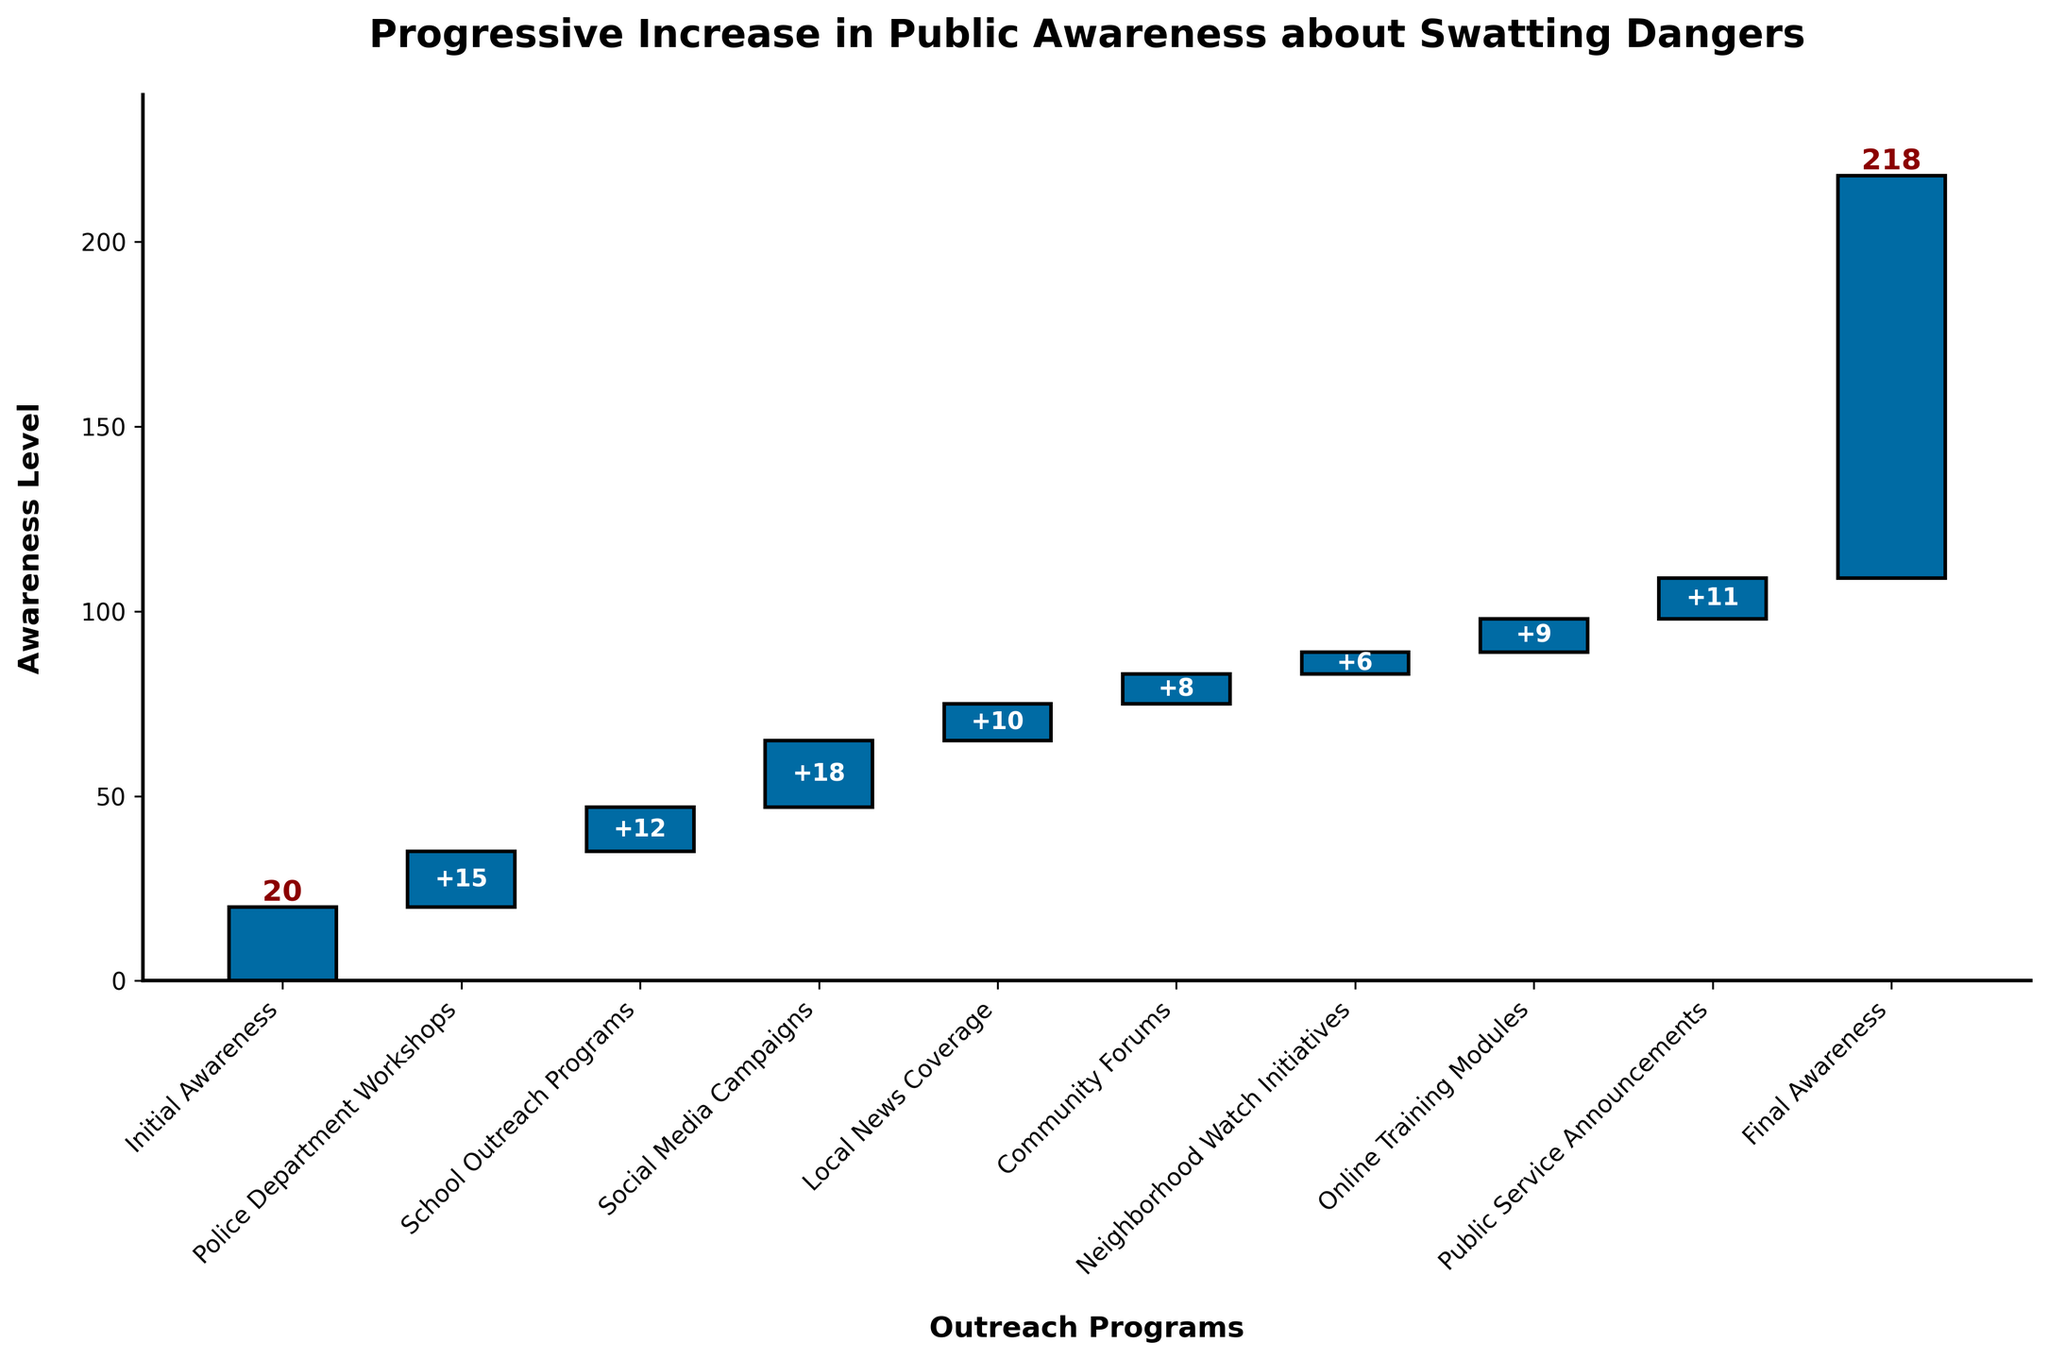What is the title of the figure? The title of the figure is found at the top of the chart. It reads "Progressive Increase in Public Awareness about Swatting Dangers".
Answer: Progressive Increase in Public Awareness about Swatting Dangers How many outreach programs are listed in the figure? Counting each unique category from the bar chart except for "Initial Awareness" and "Final Awareness" gives the total number of outreach programs. The programs are "Police Department Workshops", "School Outreach Programs", "Social Media Campaigns", "Local News Coverage", "Community Forums", "Neighborhood Watch Initiatives", "Online Training Modules", "Public Service Announcements". There are 8 programs in total.
Answer: 8 Which outreach program contributed the most to public awareness? By examining the bars, the height of each bar represents the contribution to public awareness. "Social Media Campaigns" has the tallest bar, indicating it contributed the most.
Answer: Social Media Campaigns What is the total increase in awareness from the initial to the final awareness level? To find the total increase, subtract the initial awareness level from the final awareness level. Initial Awareness is 20, and Final Awareness is 109. The calculation is 109 - 20 = 89.
Answer: 89 Which outreach program contributed the least to public awareness? By examining the bars, the shortest bar represents the smallest contribution to public awareness. "Neighborhood Watch Initiatives" has the shortest bar, indicating it contributed the least.
Answer: Neighborhood Watch Initiatives What is the combined contribution from "Online Training Modules" and "Public Service Announcements"? Adding the values of these two programs gives their combined contribution. "Online Training Modules" contributed 9 and "Public Service Announcements" contributed 11. The calculation is 9 + 11 = 20.
Answer: 20 How much did "Community Forums" and "Neighborhood Watch Initiatives" together contribute to the awareness level? Adding the values of these two programs gives their combined contribution. "Community Forums" contributed 8 and "Neighborhood Watch Initiatives" contributed 6. The calculation is 8 + 6 = 14.
Answer: 14 What is the cumulative awareness level after "School Outreach Programs"? To find the cumulative level, sum the values up to and including "School Outreach Programs". Initial Awareness is 20, Police Department Workshops is 15, and School Outreach Programs is 12. The calculation is 20 + 15 + 12 = 47.
Answer: 47 How does the contribution of "Local News Coverage" compare to "Community Forums"? Identify the values of each program. "Local News Coverage" contributed 10, and "Community Forums" contributed 8. By comparing, 10 > 8, so "Local News Coverage" contributed more.
Answer: Local News Coverage contributed more 